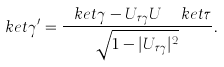Convert formula to latex. <formula><loc_0><loc_0><loc_500><loc_500>\ k e t { \gamma ^ { \prime } } = \frac { \ k e t { \gamma } - U _ { \tau \gamma } U ^ { \dagger } \ k e t { \tau } } { \sqrt { 1 - | U _ { \tau \gamma } | ^ { 2 } } } .</formula> 